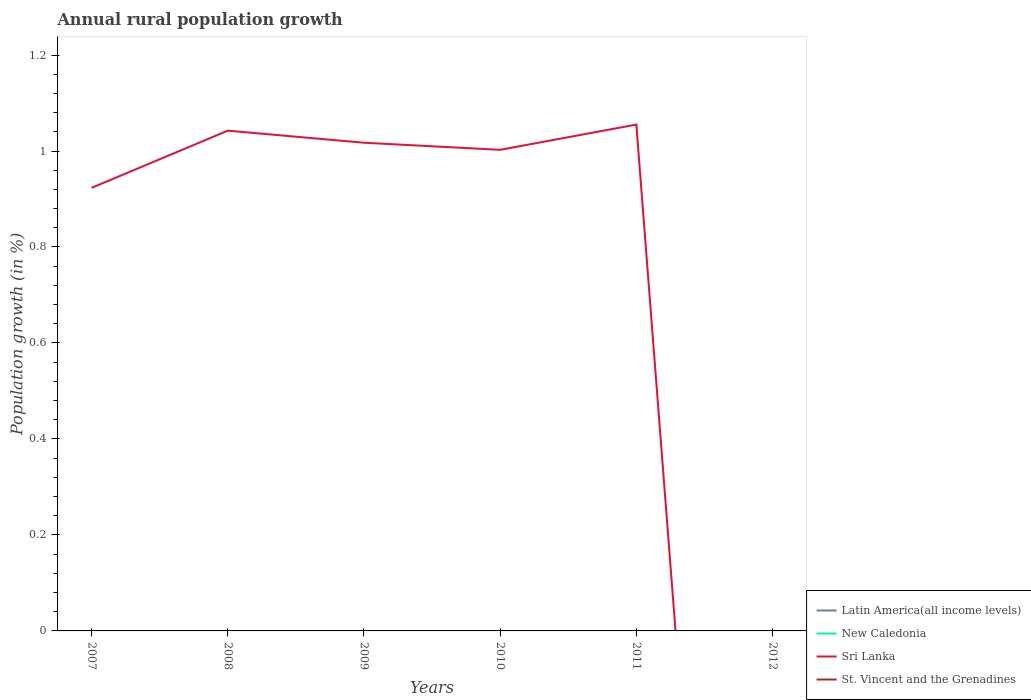Is the number of lines equal to the number of legend labels?
Make the answer very short. No. What is the total percentage of rural population growth in Sri Lanka in the graph?
Your answer should be very brief. -0.13. What is the difference between the highest and the second highest percentage of rural population growth in Sri Lanka?
Offer a terse response. 1.06. What is the difference between the highest and the lowest percentage of rural population growth in New Caledonia?
Your answer should be very brief. 0. What is the difference between two consecutive major ticks on the Y-axis?
Your answer should be very brief. 0.2. Are the values on the major ticks of Y-axis written in scientific E-notation?
Your response must be concise. No. Does the graph contain any zero values?
Provide a succinct answer. Yes. Does the graph contain grids?
Offer a terse response. No. How many legend labels are there?
Offer a terse response. 4. How are the legend labels stacked?
Provide a succinct answer. Vertical. What is the title of the graph?
Offer a very short reply. Annual rural population growth. Does "Mozambique" appear as one of the legend labels in the graph?
Your response must be concise. No. What is the label or title of the Y-axis?
Give a very brief answer. Population growth (in %). What is the Population growth (in %) of Latin America(all income levels) in 2007?
Keep it short and to the point. 0. What is the Population growth (in %) in Sri Lanka in 2007?
Offer a very short reply. 0.92. What is the Population growth (in %) of Latin America(all income levels) in 2008?
Your answer should be compact. 0. What is the Population growth (in %) of Sri Lanka in 2008?
Ensure brevity in your answer.  1.04. What is the Population growth (in %) of Latin America(all income levels) in 2009?
Offer a terse response. 0. What is the Population growth (in %) of New Caledonia in 2009?
Your answer should be compact. 0. What is the Population growth (in %) in Sri Lanka in 2009?
Your answer should be very brief. 1.02. What is the Population growth (in %) in St. Vincent and the Grenadines in 2009?
Provide a short and direct response. 0. What is the Population growth (in %) of New Caledonia in 2010?
Provide a short and direct response. 0. What is the Population growth (in %) in Sri Lanka in 2010?
Make the answer very short. 1. What is the Population growth (in %) in St. Vincent and the Grenadines in 2010?
Offer a very short reply. 0. What is the Population growth (in %) of Latin America(all income levels) in 2011?
Your answer should be very brief. 0. What is the Population growth (in %) in New Caledonia in 2011?
Offer a terse response. 0. What is the Population growth (in %) in Sri Lanka in 2011?
Offer a very short reply. 1.06. What is the Population growth (in %) of Latin America(all income levels) in 2012?
Your response must be concise. 0. What is the Population growth (in %) in New Caledonia in 2012?
Make the answer very short. 0. What is the Population growth (in %) in Sri Lanka in 2012?
Provide a short and direct response. 0. What is the Population growth (in %) of St. Vincent and the Grenadines in 2012?
Your answer should be compact. 0. Across all years, what is the maximum Population growth (in %) in Sri Lanka?
Your answer should be compact. 1.06. Across all years, what is the minimum Population growth (in %) of Sri Lanka?
Provide a short and direct response. 0. What is the total Population growth (in %) of Latin America(all income levels) in the graph?
Keep it short and to the point. 0. What is the total Population growth (in %) in New Caledonia in the graph?
Keep it short and to the point. 0. What is the total Population growth (in %) of Sri Lanka in the graph?
Your response must be concise. 5.04. What is the difference between the Population growth (in %) in Sri Lanka in 2007 and that in 2008?
Offer a terse response. -0.12. What is the difference between the Population growth (in %) in Sri Lanka in 2007 and that in 2009?
Ensure brevity in your answer.  -0.09. What is the difference between the Population growth (in %) of Sri Lanka in 2007 and that in 2010?
Your answer should be compact. -0.08. What is the difference between the Population growth (in %) in Sri Lanka in 2007 and that in 2011?
Keep it short and to the point. -0.13. What is the difference between the Population growth (in %) of Sri Lanka in 2008 and that in 2009?
Keep it short and to the point. 0.03. What is the difference between the Population growth (in %) in Sri Lanka in 2008 and that in 2010?
Ensure brevity in your answer.  0.04. What is the difference between the Population growth (in %) in Sri Lanka in 2008 and that in 2011?
Offer a terse response. -0.01. What is the difference between the Population growth (in %) in Sri Lanka in 2009 and that in 2010?
Provide a succinct answer. 0.01. What is the difference between the Population growth (in %) of Sri Lanka in 2009 and that in 2011?
Provide a succinct answer. -0.04. What is the difference between the Population growth (in %) of Sri Lanka in 2010 and that in 2011?
Make the answer very short. -0.05. What is the average Population growth (in %) of Latin America(all income levels) per year?
Provide a succinct answer. 0. What is the average Population growth (in %) of New Caledonia per year?
Your answer should be compact. 0. What is the average Population growth (in %) in Sri Lanka per year?
Your answer should be compact. 0.84. What is the average Population growth (in %) in St. Vincent and the Grenadines per year?
Your response must be concise. 0. What is the ratio of the Population growth (in %) of Sri Lanka in 2007 to that in 2008?
Your answer should be very brief. 0.89. What is the ratio of the Population growth (in %) in Sri Lanka in 2007 to that in 2009?
Your answer should be very brief. 0.91. What is the ratio of the Population growth (in %) in Sri Lanka in 2007 to that in 2010?
Your answer should be very brief. 0.92. What is the ratio of the Population growth (in %) in Sri Lanka in 2007 to that in 2011?
Provide a short and direct response. 0.88. What is the ratio of the Population growth (in %) in Sri Lanka in 2008 to that in 2009?
Keep it short and to the point. 1.02. What is the ratio of the Population growth (in %) of Sri Lanka in 2008 to that in 2010?
Your answer should be compact. 1.04. What is the ratio of the Population growth (in %) in Sri Lanka in 2008 to that in 2011?
Provide a succinct answer. 0.99. What is the ratio of the Population growth (in %) in Sri Lanka in 2009 to that in 2010?
Make the answer very short. 1.01. What is the ratio of the Population growth (in %) in Sri Lanka in 2009 to that in 2011?
Keep it short and to the point. 0.96. What is the ratio of the Population growth (in %) of Sri Lanka in 2010 to that in 2011?
Keep it short and to the point. 0.95. What is the difference between the highest and the second highest Population growth (in %) of Sri Lanka?
Offer a very short reply. 0.01. What is the difference between the highest and the lowest Population growth (in %) of Sri Lanka?
Offer a terse response. 1.06. 